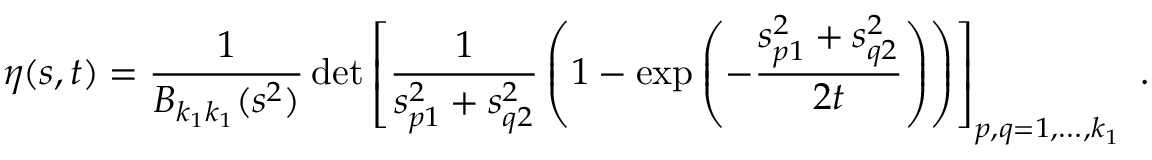Convert formula to latex. <formula><loc_0><loc_0><loc_500><loc_500>\eta ( s , t ) = \frac { 1 } { B _ { k _ { 1 } k _ { 1 } } ( s ^ { 2 } ) } \, d e t \left [ \frac { 1 } { s _ { p 1 } ^ { 2 } + s _ { q 2 } ^ { 2 } } \left ( 1 - \exp \left ( - \frac { s _ { p 1 } ^ { 2 } + s _ { q 2 } ^ { 2 } } { 2 t } \right ) \right ) \right ] _ { p , q = 1 , \dots , k _ { 1 } } \ .</formula> 